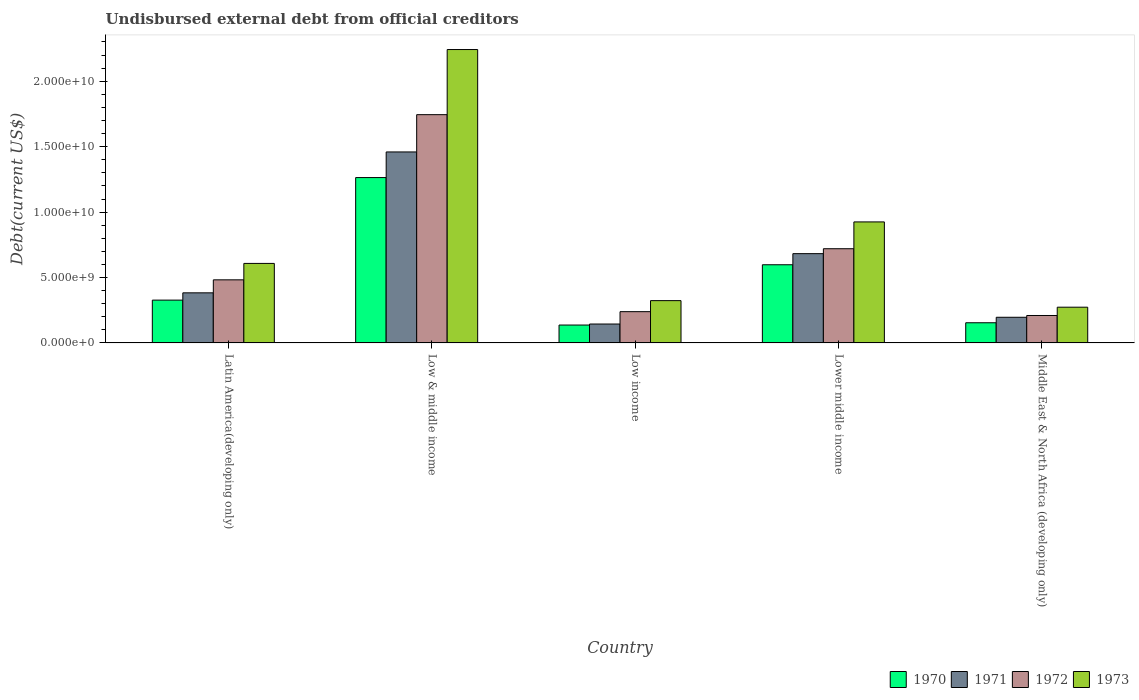How many different coloured bars are there?
Offer a very short reply. 4. How many groups of bars are there?
Your response must be concise. 5. Are the number of bars per tick equal to the number of legend labels?
Your answer should be very brief. Yes. Are the number of bars on each tick of the X-axis equal?
Ensure brevity in your answer.  Yes. How many bars are there on the 2nd tick from the left?
Offer a very short reply. 4. How many bars are there on the 2nd tick from the right?
Your answer should be very brief. 4. What is the label of the 1st group of bars from the left?
Your response must be concise. Latin America(developing only). What is the total debt in 1970 in Low & middle income?
Make the answer very short. 1.26e+1. Across all countries, what is the maximum total debt in 1971?
Give a very brief answer. 1.46e+1. Across all countries, what is the minimum total debt in 1970?
Make the answer very short. 1.37e+09. In which country was the total debt in 1971 maximum?
Your response must be concise. Low & middle income. In which country was the total debt in 1973 minimum?
Make the answer very short. Middle East & North Africa (developing only). What is the total total debt in 1970 in the graph?
Offer a very short reply. 2.48e+1. What is the difference between the total debt in 1971 in Latin America(developing only) and that in Low income?
Your answer should be very brief. 2.38e+09. What is the difference between the total debt in 1972 in Lower middle income and the total debt in 1971 in Latin America(developing only)?
Offer a very short reply. 3.37e+09. What is the average total debt in 1973 per country?
Make the answer very short. 8.74e+09. What is the difference between the total debt of/in 1972 and total debt of/in 1971 in Lower middle income?
Ensure brevity in your answer.  3.77e+08. In how many countries, is the total debt in 1973 greater than 20000000000 US$?
Offer a very short reply. 1. What is the ratio of the total debt in 1972 in Low income to that in Middle East & North Africa (developing only)?
Your answer should be very brief. 1.14. Is the difference between the total debt in 1972 in Lower middle income and Middle East & North Africa (developing only) greater than the difference between the total debt in 1971 in Lower middle income and Middle East & North Africa (developing only)?
Keep it short and to the point. Yes. What is the difference between the highest and the second highest total debt in 1972?
Keep it short and to the point. 1.02e+1. What is the difference between the highest and the lowest total debt in 1973?
Provide a succinct answer. 1.97e+1. In how many countries, is the total debt in 1973 greater than the average total debt in 1973 taken over all countries?
Give a very brief answer. 2. Is the sum of the total debt in 1973 in Low & middle income and Middle East & North Africa (developing only) greater than the maximum total debt in 1972 across all countries?
Your answer should be very brief. Yes. Is it the case that in every country, the sum of the total debt in 1970 and total debt in 1971 is greater than the total debt in 1973?
Offer a terse response. No. What is the difference between two consecutive major ticks on the Y-axis?
Make the answer very short. 5.00e+09. Are the values on the major ticks of Y-axis written in scientific E-notation?
Give a very brief answer. Yes. Does the graph contain any zero values?
Your answer should be very brief. No. How are the legend labels stacked?
Your response must be concise. Horizontal. What is the title of the graph?
Make the answer very short. Undisbursed external debt from official creditors. What is the label or title of the Y-axis?
Provide a succinct answer. Debt(current US$). What is the Debt(current US$) in 1970 in Latin America(developing only)?
Your response must be concise. 3.27e+09. What is the Debt(current US$) of 1971 in Latin America(developing only)?
Provide a succinct answer. 3.83e+09. What is the Debt(current US$) of 1972 in Latin America(developing only)?
Your answer should be very brief. 4.82e+09. What is the Debt(current US$) in 1973 in Latin America(developing only)?
Keep it short and to the point. 6.08e+09. What is the Debt(current US$) of 1970 in Low & middle income?
Keep it short and to the point. 1.26e+1. What is the Debt(current US$) in 1971 in Low & middle income?
Provide a short and direct response. 1.46e+1. What is the Debt(current US$) of 1972 in Low & middle income?
Keep it short and to the point. 1.74e+1. What is the Debt(current US$) in 1973 in Low & middle income?
Your answer should be very brief. 2.24e+1. What is the Debt(current US$) in 1970 in Low income?
Ensure brevity in your answer.  1.37e+09. What is the Debt(current US$) of 1971 in Low income?
Your response must be concise. 1.45e+09. What is the Debt(current US$) in 1972 in Low income?
Give a very brief answer. 2.39e+09. What is the Debt(current US$) in 1973 in Low income?
Offer a terse response. 3.23e+09. What is the Debt(current US$) in 1970 in Lower middle income?
Offer a terse response. 5.98e+09. What is the Debt(current US$) of 1971 in Lower middle income?
Make the answer very short. 6.82e+09. What is the Debt(current US$) of 1972 in Lower middle income?
Your answer should be very brief. 7.20e+09. What is the Debt(current US$) in 1973 in Lower middle income?
Provide a succinct answer. 9.25e+09. What is the Debt(current US$) of 1970 in Middle East & North Africa (developing only)?
Provide a short and direct response. 1.54e+09. What is the Debt(current US$) of 1971 in Middle East & North Africa (developing only)?
Your answer should be compact. 1.96e+09. What is the Debt(current US$) in 1972 in Middle East & North Africa (developing only)?
Offer a terse response. 2.10e+09. What is the Debt(current US$) in 1973 in Middle East & North Africa (developing only)?
Keep it short and to the point. 2.73e+09. Across all countries, what is the maximum Debt(current US$) in 1970?
Keep it short and to the point. 1.26e+1. Across all countries, what is the maximum Debt(current US$) in 1971?
Give a very brief answer. 1.46e+1. Across all countries, what is the maximum Debt(current US$) in 1972?
Give a very brief answer. 1.74e+1. Across all countries, what is the maximum Debt(current US$) of 1973?
Your answer should be very brief. 2.24e+1. Across all countries, what is the minimum Debt(current US$) in 1970?
Give a very brief answer. 1.37e+09. Across all countries, what is the minimum Debt(current US$) of 1971?
Provide a succinct answer. 1.45e+09. Across all countries, what is the minimum Debt(current US$) of 1972?
Your response must be concise. 2.10e+09. Across all countries, what is the minimum Debt(current US$) in 1973?
Ensure brevity in your answer.  2.73e+09. What is the total Debt(current US$) of 1970 in the graph?
Your answer should be compact. 2.48e+1. What is the total Debt(current US$) of 1971 in the graph?
Make the answer very short. 2.87e+1. What is the total Debt(current US$) of 1972 in the graph?
Your answer should be compact. 3.40e+1. What is the total Debt(current US$) of 1973 in the graph?
Provide a succinct answer. 4.37e+1. What is the difference between the Debt(current US$) of 1970 in Latin America(developing only) and that in Low & middle income?
Make the answer very short. -9.37e+09. What is the difference between the Debt(current US$) in 1971 in Latin America(developing only) and that in Low & middle income?
Make the answer very short. -1.08e+1. What is the difference between the Debt(current US$) of 1972 in Latin America(developing only) and that in Low & middle income?
Keep it short and to the point. -1.26e+1. What is the difference between the Debt(current US$) in 1973 in Latin America(developing only) and that in Low & middle income?
Make the answer very short. -1.63e+1. What is the difference between the Debt(current US$) of 1970 in Latin America(developing only) and that in Low income?
Provide a short and direct response. 1.90e+09. What is the difference between the Debt(current US$) of 1971 in Latin America(developing only) and that in Low income?
Give a very brief answer. 2.38e+09. What is the difference between the Debt(current US$) in 1972 in Latin America(developing only) and that in Low income?
Offer a very short reply. 2.43e+09. What is the difference between the Debt(current US$) in 1973 in Latin America(developing only) and that in Low income?
Provide a short and direct response. 2.84e+09. What is the difference between the Debt(current US$) of 1970 in Latin America(developing only) and that in Lower middle income?
Provide a short and direct response. -2.70e+09. What is the difference between the Debt(current US$) of 1971 in Latin America(developing only) and that in Lower middle income?
Offer a terse response. -2.99e+09. What is the difference between the Debt(current US$) in 1972 in Latin America(developing only) and that in Lower middle income?
Ensure brevity in your answer.  -2.38e+09. What is the difference between the Debt(current US$) of 1973 in Latin America(developing only) and that in Lower middle income?
Your answer should be compact. -3.17e+09. What is the difference between the Debt(current US$) in 1970 in Latin America(developing only) and that in Middle East & North Africa (developing only)?
Offer a terse response. 1.73e+09. What is the difference between the Debt(current US$) in 1971 in Latin America(developing only) and that in Middle East & North Africa (developing only)?
Provide a succinct answer. 1.87e+09. What is the difference between the Debt(current US$) in 1972 in Latin America(developing only) and that in Middle East & North Africa (developing only)?
Provide a succinct answer. 2.73e+09. What is the difference between the Debt(current US$) of 1973 in Latin America(developing only) and that in Middle East & North Africa (developing only)?
Keep it short and to the point. 3.35e+09. What is the difference between the Debt(current US$) of 1970 in Low & middle income and that in Low income?
Your answer should be compact. 1.13e+1. What is the difference between the Debt(current US$) in 1971 in Low & middle income and that in Low income?
Your answer should be compact. 1.32e+1. What is the difference between the Debt(current US$) of 1972 in Low & middle income and that in Low income?
Keep it short and to the point. 1.51e+1. What is the difference between the Debt(current US$) in 1973 in Low & middle income and that in Low income?
Your answer should be very brief. 1.92e+1. What is the difference between the Debt(current US$) in 1970 in Low & middle income and that in Lower middle income?
Ensure brevity in your answer.  6.66e+09. What is the difference between the Debt(current US$) in 1971 in Low & middle income and that in Lower middle income?
Offer a very short reply. 7.77e+09. What is the difference between the Debt(current US$) in 1972 in Low & middle income and that in Lower middle income?
Offer a very short reply. 1.02e+1. What is the difference between the Debt(current US$) in 1973 in Low & middle income and that in Lower middle income?
Your answer should be very brief. 1.32e+1. What is the difference between the Debt(current US$) of 1970 in Low & middle income and that in Middle East & North Africa (developing only)?
Keep it short and to the point. 1.11e+1. What is the difference between the Debt(current US$) of 1971 in Low & middle income and that in Middle East & North Africa (developing only)?
Offer a very short reply. 1.26e+1. What is the difference between the Debt(current US$) in 1972 in Low & middle income and that in Middle East & North Africa (developing only)?
Your answer should be very brief. 1.53e+1. What is the difference between the Debt(current US$) in 1973 in Low & middle income and that in Middle East & North Africa (developing only)?
Offer a terse response. 1.97e+1. What is the difference between the Debt(current US$) in 1970 in Low income and that in Lower middle income?
Your answer should be very brief. -4.61e+09. What is the difference between the Debt(current US$) of 1971 in Low income and that in Lower middle income?
Your answer should be compact. -5.38e+09. What is the difference between the Debt(current US$) in 1972 in Low income and that in Lower middle income?
Your answer should be very brief. -4.81e+09. What is the difference between the Debt(current US$) in 1973 in Low income and that in Lower middle income?
Your response must be concise. -6.02e+09. What is the difference between the Debt(current US$) in 1970 in Low income and that in Middle East & North Africa (developing only)?
Keep it short and to the point. -1.75e+08. What is the difference between the Debt(current US$) in 1971 in Low income and that in Middle East & North Africa (developing only)?
Offer a very short reply. -5.16e+08. What is the difference between the Debt(current US$) of 1972 in Low income and that in Middle East & North Africa (developing only)?
Your answer should be very brief. 2.93e+08. What is the difference between the Debt(current US$) in 1973 in Low income and that in Middle East & North Africa (developing only)?
Your answer should be very brief. 5.02e+08. What is the difference between the Debt(current US$) in 1970 in Lower middle income and that in Middle East & North Africa (developing only)?
Your response must be concise. 4.43e+09. What is the difference between the Debt(current US$) of 1971 in Lower middle income and that in Middle East & North Africa (developing only)?
Provide a short and direct response. 4.86e+09. What is the difference between the Debt(current US$) in 1972 in Lower middle income and that in Middle East & North Africa (developing only)?
Your response must be concise. 5.10e+09. What is the difference between the Debt(current US$) in 1973 in Lower middle income and that in Middle East & North Africa (developing only)?
Give a very brief answer. 6.52e+09. What is the difference between the Debt(current US$) in 1970 in Latin America(developing only) and the Debt(current US$) in 1971 in Low & middle income?
Your answer should be very brief. -1.13e+1. What is the difference between the Debt(current US$) of 1970 in Latin America(developing only) and the Debt(current US$) of 1972 in Low & middle income?
Make the answer very short. -1.42e+1. What is the difference between the Debt(current US$) of 1970 in Latin America(developing only) and the Debt(current US$) of 1973 in Low & middle income?
Provide a succinct answer. -1.91e+1. What is the difference between the Debt(current US$) of 1971 in Latin America(developing only) and the Debt(current US$) of 1972 in Low & middle income?
Keep it short and to the point. -1.36e+1. What is the difference between the Debt(current US$) in 1971 in Latin America(developing only) and the Debt(current US$) in 1973 in Low & middle income?
Your response must be concise. -1.86e+1. What is the difference between the Debt(current US$) of 1972 in Latin America(developing only) and the Debt(current US$) of 1973 in Low & middle income?
Give a very brief answer. -1.76e+1. What is the difference between the Debt(current US$) in 1970 in Latin America(developing only) and the Debt(current US$) in 1971 in Low income?
Keep it short and to the point. 1.83e+09. What is the difference between the Debt(current US$) of 1970 in Latin America(developing only) and the Debt(current US$) of 1972 in Low income?
Provide a succinct answer. 8.81e+08. What is the difference between the Debt(current US$) in 1970 in Latin America(developing only) and the Debt(current US$) in 1973 in Low income?
Offer a very short reply. 3.84e+07. What is the difference between the Debt(current US$) in 1971 in Latin America(developing only) and the Debt(current US$) in 1972 in Low income?
Offer a terse response. 1.44e+09. What is the difference between the Debt(current US$) in 1971 in Latin America(developing only) and the Debt(current US$) in 1973 in Low income?
Your answer should be compact. 5.95e+08. What is the difference between the Debt(current US$) of 1972 in Latin America(developing only) and the Debt(current US$) of 1973 in Low income?
Your answer should be compact. 1.59e+09. What is the difference between the Debt(current US$) of 1970 in Latin America(developing only) and the Debt(current US$) of 1971 in Lower middle income?
Your response must be concise. -3.55e+09. What is the difference between the Debt(current US$) in 1970 in Latin America(developing only) and the Debt(current US$) in 1972 in Lower middle income?
Your answer should be compact. -3.93e+09. What is the difference between the Debt(current US$) of 1970 in Latin America(developing only) and the Debt(current US$) of 1973 in Lower middle income?
Offer a terse response. -5.98e+09. What is the difference between the Debt(current US$) in 1971 in Latin America(developing only) and the Debt(current US$) in 1972 in Lower middle income?
Make the answer very short. -3.37e+09. What is the difference between the Debt(current US$) in 1971 in Latin America(developing only) and the Debt(current US$) in 1973 in Lower middle income?
Provide a short and direct response. -5.42e+09. What is the difference between the Debt(current US$) of 1972 in Latin America(developing only) and the Debt(current US$) of 1973 in Lower middle income?
Ensure brevity in your answer.  -4.43e+09. What is the difference between the Debt(current US$) in 1970 in Latin America(developing only) and the Debt(current US$) in 1971 in Middle East & North Africa (developing only)?
Your response must be concise. 1.31e+09. What is the difference between the Debt(current US$) in 1970 in Latin America(developing only) and the Debt(current US$) in 1972 in Middle East & North Africa (developing only)?
Your response must be concise. 1.17e+09. What is the difference between the Debt(current US$) in 1970 in Latin America(developing only) and the Debt(current US$) in 1973 in Middle East & North Africa (developing only)?
Provide a short and direct response. 5.40e+08. What is the difference between the Debt(current US$) in 1971 in Latin America(developing only) and the Debt(current US$) in 1972 in Middle East & North Africa (developing only)?
Ensure brevity in your answer.  1.73e+09. What is the difference between the Debt(current US$) of 1971 in Latin America(developing only) and the Debt(current US$) of 1973 in Middle East & North Africa (developing only)?
Your response must be concise. 1.10e+09. What is the difference between the Debt(current US$) of 1972 in Latin America(developing only) and the Debt(current US$) of 1973 in Middle East & North Africa (developing only)?
Your response must be concise. 2.09e+09. What is the difference between the Debt(current US$) of 1970 in Low & middle income and the Debt(current US$) of 1971 in Low income?
Keep it short and to the point. 1.12e+1. What is the difference between the Debt(current US$) in 1970 in Low & middle income and the Debt(current US$) in 1972 in Low income?
Offer a terse response. 1.02e+1. What is the difference between the Debt(current US$) in 1970 in Low & middle income and the Debt(current US$) in 1973 in Low income?
Your answer should be compact. 9.40e+09. What is the difference between the Debt(current US$) of 1971 in Low & middle income and the Debt(current US$) of 1972 in Low income?
Offer a terse response. 1.22e+1. What is the difference between the Debt(current US$) in 1971 in Low & middle income and the Debt(current US$) in 1973 in Low income?
Keep it short and to the point. 1.14e+1. What is the difference between the Debt(current US$) of 1972 in Low & middle income and the Debt(current US$) of 1973 in Low income?
Ensure brevity in your answer.  1.42e+1. What is the difference between the Debt(current US$) in 1970 in Low & middle income and the Debt(current US$) in 1971 in Lower middle income?
Provide a succinct answer. 5.81e+09. What is the difference between the Debt(current US$) in 1970 in Low & middle income and the Debt(current US$) in 1972 in Lower middle income?
Keep it short and to the point. 5.44e+09. What is the difference between the Debt(current US$) of 1970 in Low & middle income and the Debt(current US$) of 1973 in Lower middle income?
Your response must be concise. 3.39e+09. What is the difference between the Debt(current US$) of 1971 in Low & middle income and the Debt(current US$) of 1972 in Lower middle income?
Your answer should be very brief. 7.40e+09. What is the difference between the Debt(current US$) in 1971 in Low & middle income and the Debt(current US$) in 1973 in Lower middle income?
Offer a very short reply. 5.35e+09. What is the difference between the Debt(current US$) of 1972 in Low & middle income and the Debt(current US$) of 1973 in Lower middle income?
Make the answer very short. 8.20e+09. What is the difference between the Debt(current US$) in 1970 in Low & middle income and the Debt(current US$) in 1971 in Middle East & North Africa (developing only)?
Provide a succinct answer. 1.07e+1. What is the difference between the Debt(current US$) in 1970 in Low & middle income and the Debt(current US$) in 1972 in Middle East & North Africa (developing only)?
Your response must be concise. 1.05e+1. What is the difference between the Debt(current US$) of 1970 in Low & middle income and the Debt(current US$) of 1973 in Middle East & North Africa (developing only)?
Ensure brevity in your answer.  9.91e+09. What is the difference between the Debt(current US$) of 1971 in Low & middle income and the Debt(current US$) of 1972 in Middle East & North Africa (developing only)?
Ensure brevity in your answer.  1.25e+1. What is the difference between the Debt(current US$) of 1971 in Low & middle income and the Debt(current US$) of 1973 in Middle East & North Africa (developing only)?
Keep it short and to the point. 1.19e+1. What is the difference between the Debt(current US$) of 1972 in Low & middle income and the Debt(current US$) of 1973 in Middle East & North Africa (developing only)?
Your answer should be compact. 1.47e+1. What is the difference between the Debt(current US$) of 1970 in Low income and the Debt(current US$) of 1971 in Lower middle income?
Make the answer very short. -5.46e+09. What is the difference between the Debt(current US$) in 1970 in Low income and the Debt(current US$) in 1972 in Lower middle income?
Keep it short and to the point. -5.83e+09. What is the difference between the Debt(current US$) in 1970 in Low income and the Debt(current US$) in 1973 in Lower middle income?
Make the answer very short. -7.88e+09. What is the difference between the Debt(current US$) of 1971 in Low income and the Debt(current US$) of 1972 in Lower middle income?
Your response must be concise. -5.75e+09. What is the difference between the Debt(current US$) of 1971 in Low income and the Debt(current US$) of 1973 in Lower middle income?
Make the answer very short. -7.80e+09. What is the difference between the Debt(current US$) in 1972 in Low income and the Debt(current US$) in 1973 in Lower middle income?
Provide a short and direct response. -6.86e+09. What is the difference between the Debt(current US$) of 1970 in Low income and the Debt(current US$) of 1971 in Middle East & North Africa (developing only)?
Keep it short and to the point. -5.94e+08. What is the difference between the Debt(current US$) in 1970 in Low income and the Debt(current US$) in 1972 in Middle East & North Africa (developing only)?
Your answer should be very brief. -7.30e+08. What is the difference between the Debt(current US$) of 1970 in Low income and the Debt(current US$) of 1973 in Middle East & North Africa (developing only)?
Offer a very short reply. -1.36e+09. What is the difference between the Debt(current US$) of 1971 in Low income and the Debt(current US$) of 1972 in Middle East & North Africa (developing only)?
Your answer should be very brief. -6.51e+08. What is the difference between the Debt(current US$) of 1971 in Low income and the Debt(current US$) of 1973 in Middle East & North Africa (developing only)?
Offer a terse response. -1.29e+09. What is the difference between the Debt(current US$) in 1972 in Low income and the Debt(current US$) in 1973 in Middle East & North Africa (developing only)?
Provide a succinct answer. -3.41e+08. What is the difference between the Debt(current US$) of 1970 in Lower middle income and the Debt(current US$) of 1971 in Middle East & North Africa (developing only)?
Make the answer very short. 4.01e+09. What is the difference between the Debt(current US$) of 1970 in Lower middle income and the Debt(current US$) of 1972 in Middle East & North Africa (developing only)?
Your response must be concise. 3.88e+09. What is the difference between the Debt(current US$) in 1970 in Lower middle income and the Debt(current US$) in 1973 in Middle East & North Africa (developing only)?
Offer a terse response. 3.24e+09. What is the difference between the Debt(current US$) of 1971 in Lower middle income and the Debt(current US$) of 1972 in Middle East & North Africa (developing only)?
Offer a terse response. 4.73e+09. What is the difference between the Debt(current US$) of 1971 in Lower middle income and the Debt(current US$) of 1973 in Middle East & North Africa (developing only)?
Ensure brevity in your answer.  4.09e+09. What is the difference between the Debt(current US$) of 1972 in Lower middle income and the Debt(current US$) of 1973 in Middle East & North Africa (developing only)?
Provide a short and direct response. 4.47e+09. What is the average Debt(current US$) of 1970 per country?
Provide a short and direct response. 4.96e+09. What is the average Debt(current US$) in 1971 per country?
Keep it short and to the point. 5.73e+09. What is the average Debt(current US$) of 1972 per country?
Provide a succinct answer. 6.79e+09. What is the average Debt(current US$) in 1973 per country?
Keep it short and to the point. 8.74e+09. What is the difference between the Debt(current US$) of 1970 and Debt(current US$) of 1971 in Latin America(developing only)?
Your response must be concise. -5.57e+08. What is the difference between the Debt(current US$) of 1970 and Debt(current US$) of 1972 in Latin America(developing only)?
Provide a succinct answer. -1.55e+09. What is the difference between the Debt(current US$) of 1970 and Debt(current US$) of 1973 in Latin America(developing only)?
Keep it short and to the point. -2.81e+09. What is the difference between the Debt(current US$) in 1971 and Debt(current US$) in 1972 in Latin America(developing only)?
Give a very brief answer. -9.94e+08. What is the difference between the Debt(current US$) of 1971 and Debt(current US$) of 1973 in Latin America(developing only)?
Offer a terse response. -2.25e+09. What is the difference between the Debt(current US$) of 1972 and Debt(current US$) of 1973 in Latin America(developing only)?
Give a very brief answer. -1.26e+09. What is the difference between the Debt(current US$) in 1970 and Debt(current US$) in 1971 in Low & middle income?
Provide a short and direct response. -1.96e+09. What is the difference between the Debt(current US$) of 1970 and Debt(current US$) of 1972 in Low & middle income?
Offer a very short reply. -4.81e+09. What is the difference between the Debt(current US$) of 1970 and Debt(current US$) of 1973 in Low & middle income?
Keep it short and to the point. -9.78e+09. What is the difference between the Debt(current US$) of 1971 and Debt(current US$) of 1972 in Low & middle income?
Provide a succinct answer. -2.85e+09. What is the difference between the Debt(current US$) of 1971 and Debt(current US$) of 1973 in Low & middle income?
Make the answer very short. -7.83e+09. What is the difference between the Debt(current US$) in 1972 and Debt(current US$) in 1973 in Low & middle income?
Your answer should be compact. -4.98e+09. What is the difference between the Debt(current US$) of 1970 and Debt(current US$) of 1971 in Low income?
Your answer should be compact. -7.83e+07. What is the difference between the Debt(current US$) in 1970 and Debt(current US$) in 1972 in Low income?
Provide a succinct answer. -1.02e+09. What is the difference between the Debt(current US$) of 1970 and Debt(current US$) of 1973 in Low income?
Your answer should be very brief. -1.87e+09. What is the difference between the Debt(current US$) in 1971 and Debt(current US$) in 1972 in Low income?
Your answer should be very brief. -9.45e+08. What is the difference between the Debt(current US$) in 1971 and Debt(current US$) in 1973 in Low income?
Provide a succinct answer. -1.79e+09. What is the difference between the Debt(current US$) of 1972 and Debt(current US$) of 1973 in Low income?
Your answer should be compact. -8.43e+08. What is the difference between the Debt(current US$) in 1970 and Debt(current US$) in 1971 in Lower middle income?
Provide a succinct answer. -8.48e+08. What is the difference between the Debt(current US$) of 1970 and Debt(current US$) of 1972 in Lower middle income?
Offer a terse response. -1.22e+09. What is the difference between the Debt(current US$) of 1970 and Debt(current US$) of 1973 in Lower middle income?
Provide a short and direct response. -3.27e+09. What is the difference between the Debt(current US$) in 1971 and Debt(current US$) in 1972 in Lower middle income?
Offer a very short reply. -3.77e+08. What is the difference between the Debt(current US$) in 1971 and Debt(current US$) in 1973 in Lower middle income?
Give a very brief answer. -2.43e+09. What is the difference between the Debt(current US$) in 1972 and Debt(current US$) in 1973 in Lower middle income?
Provide a short and direct response. -2.05e+09. What is the difference between the Debt(current US$) of 1970 and Debt(current US$) of 1971 in Middle East & North Africa (developing only)?
Make the answer very short. -4.19e+08. What is the difference between the Debt(current US$) of 1970 and Debt(current US$) of 1972 in Middle East & North Africa (developing only)?
Make the answer very short. -5.55e+08. What is the difference between the Debt(current US$) in 1970 and Debt(current US$) in 1973 in Middle East & North Africa (developing only)?
Make the answer very short. -1.19e+09. What is the difference between the Debt(current US$) of 1971 and Debt(current US$) of 1972 in Middle East & North Africa (developing only)?
Make the answer very short. -1.35e+08. What is the difference between the Debt(current US$) in 1971 and Debt(current US$) in 1973 in Middle East & North Africa (developing only)?
Your answer should be very brief. -7.70e+08. What is the difference between the Debt(current US$) of 1972 and Debt(current US$) of 1973 in Middle East & North Africa (developing only)?
Give a very brief answer. -6.34e+08. What is the ratio of the Debt(current US$) of 1970 in Latin America(developing only) to that in Low & middle income?
Offer a terse response. 0.26. What is the ratio of the Debt(current US$) in 1971 in Latin America(developing only) to that in Low & middle income?
Keep it short and to the point. 0.26. What is the ratio of the Debt(current US$) in 1972 in Latin America(developing only) to that in Low & middle income?
Make the answer very short. 0.28. What is the ratio of the Debt(current US$) of 1973 in Latin America(developing only) to that in Low & middle income?
Make the answer very short. 0.27. What is the ratio of the Debt(current US$) of 1970 in Latin America(developing only) to that in Low income?
Offer a terse response. 2.39. What is the ratio of the Debt(current US$) in 1971 in Latin America(developing only) to that in Low income?
Keep it short and to the point. 2.65. What is the ratio of the Debt(current US$) in 1972 in Latin America(developing only) to that in Low income?
Your answer should be very brief. 2.02. What is the ratio of the Debt(current US$) of 1973 in Latin America(developing only) to that in Low income?
Give a very brief answer. 1.88. What is the ratio of the Debt(current US$) of 1970 in Latin America(developing only) to that in Lower middle income?
Offer a very short reply. 0.55. What is the ratio of the Debt(current US$) in 1971 in Latin America(developing only) to that in Lower middle income?
Give a very brief answer. 0.56. What is the ratio of the Debt(current US$) in 1972 in Latin America(developing only) to that in Lower middle income?
Offer a terse response. 0.67. What is the ratio of the Debt(current US$) of 1973 in Latin America(developing only) to that in Lower middle income?
Provide a succinct answer. 0.66. What is the ratio of the Debt(current US$) of 1970 in Latin America(developing only) to that in Middle East & North Africa (developing only)?
Keep it short and to the point. 2.12. What is the ratio of the Debt(current US$) of 1971 in Latin America(developing only) to that in Middle East & North Africa (developing only)?
Keep it short and to the point. 1.95. What is the ratio of the Debt(current US$) in 1972 in Latin America(developing only) to that in Middle East & North Africa (developing only)?
Provide a succinct answer. 2.3. What is the ratio of the Debt(current US$) of 1973 in Latin America(developing only) to that in Middle East & North Africa (developing only)?
Keep it short and to the point. 2.22. What is the ratio of the Debt(current US$) of 1970 in Low & middle income to that in Low income?
Provide a short and direct response. 9.24. What is the ratio of the Debt(current US$) in 1971 in Low & middle income to that in Low income?
Offer a terse response. 10.09. What is the ratio of the Debt(current US$) of 1972 in Low & middle income to that in Low income?
Offer a very short reply. 7.3. What is the ratio of the Debt(current US$) of 1973 in Low & middle income to that in Low income?
Keep it short and to the point. 6.93. What is the ratio of the Debt(current US$) in 1970 in Low & middle income to that in Lower middle income?
Your answer should be very brief. 2.12. What is the ratio of the Debt(current US$) of 1971 in Low & middle income to that in Lower middle income?
Offer a terse response. 2.14. What is the ratio of the Debt(current US$) of 1972 in Low & middle income to that in Lower middle income?
Provide a short and direct response. 2.42. What is the ratio of the Debt(current US$) of 1973 in Low & middle income to that in Lower middle income?
Your answer should be very brief. 2.42. What is the ratio of the Debt(current US$) of 1970 in Low & middle income to that in Middle East & North Africa (developing only)?
Make the answer very short. 8.19. What is the ratio of the Debt(current US$) in 1971 in Low & middle income to that in Middle East & North Africa (developing only)?
Your answer should be very brief. 7.44. What is the ratio of the Debt(current US$) of 1972 in Low & middle income to that in Middle East & North Africa (developing only)?
Your answer should be very brief. 8.32. What is the ratio of the Debt(current US$) in 1973 in Low & middle income to that in Middle East & North Africa (developing only)?
Provide a short and direct response. 8.21. What is the ratio of the Debt(current US$) in 1970 in Low income to that in Lower middle income?
Ensure brevity in your answer.  0.23. What is the ratio of the Debt(current US$) of 1971 in Low income to that in Lower middle income?
Provide a short and direct response. 0.21. What is the ratio of the Debt(current US$) of 1972 in Low income to that in Lower middle income?
Provide a succinct answer. 0.33. What is the ratio of the Debt(current US$) in 1973 in Low income to that in Lower middle income?
Offer a terse response. 0.35. What is the ratio of the Debt(current US$) of 1970 in Low income to that in Middle East & North Africa (developing only)?
Offer a very short reply. 0.89. What is the ratio of the Debt(current US$) in 1971 in Low income to that in Middle East & North Africa (developing only)?
Ensure brevity in your answer.  0.74. What is the ratio of the Debt(current US$) of 1972 in Low income to that in Middle East & North Africa (developing only)?
Provide a short and direct response. 1.14. What is the ratio of the Debt(current US$) in 1973 in Low income to that in Middle East & North Africa (developing only)?
Provide a short and direct response. 1.18. What is the ratio of the Debt(current US$) in 1970 in Lower middle income to that in Middle East & North Africa (developing only)?
Give a very brief answer. 3.87. What is the ratio of the Debt(current US$) in 1971 in Lower middle income to that in Middle East & North Africa (developing only)?
Your response must be concise. 3.48. What is the ratio of the Debt(current US$) in 1972 in Lower middle income to that in Middle East & North Africa (developing only)?
Give a very brief answer. 3.43. What is the ratio of the Debt(current US$) of 1973 in Lower middle income to that in Middle East & North Africa (developing only)?
Offer a terse response. 3.39. What is the difference between the highest and the second highest Debt(current US$) of 1970?
Your response must be concise. 6.66e+09. What is the difference between the highest and the second highest Debt(current US$) in 1971?
Your response must be concise. 7.77e+09. What is the difference between the highest and the second highest Debt(current US$) of 1972?
Your response must be concise. 1.02e+1. What is the difference between the highest and the second highest Debt(current US$) in 1973?
Keep it short and to the point. 1.32e+1. What is the difference between the highest and the lowest Debt(current US$) of 1970?
Keep it short and to the point. 1.13e+1. What is the difference between the highest and the lowest Debt(current US$) of 1971?
Keep it short and to the point. 1.32e+1. What is the difference between the highest and the lowest Debt(current US$) of 1972?
Offer a very short reply. 1.53e+1. What is the difference between the highest and the lowest Debt(current US$) of 1973?
Make the answer very short. 1.97e+1. 